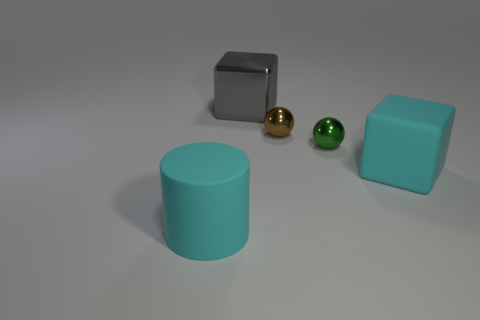How many objects are there, and can you describe their arrangement? There are five objects in total, arranged from left to right with slight variation in depth: a cylinder, followed by a cube, then a small green sphere, next to it a golden sphere, and lastly another cube. 